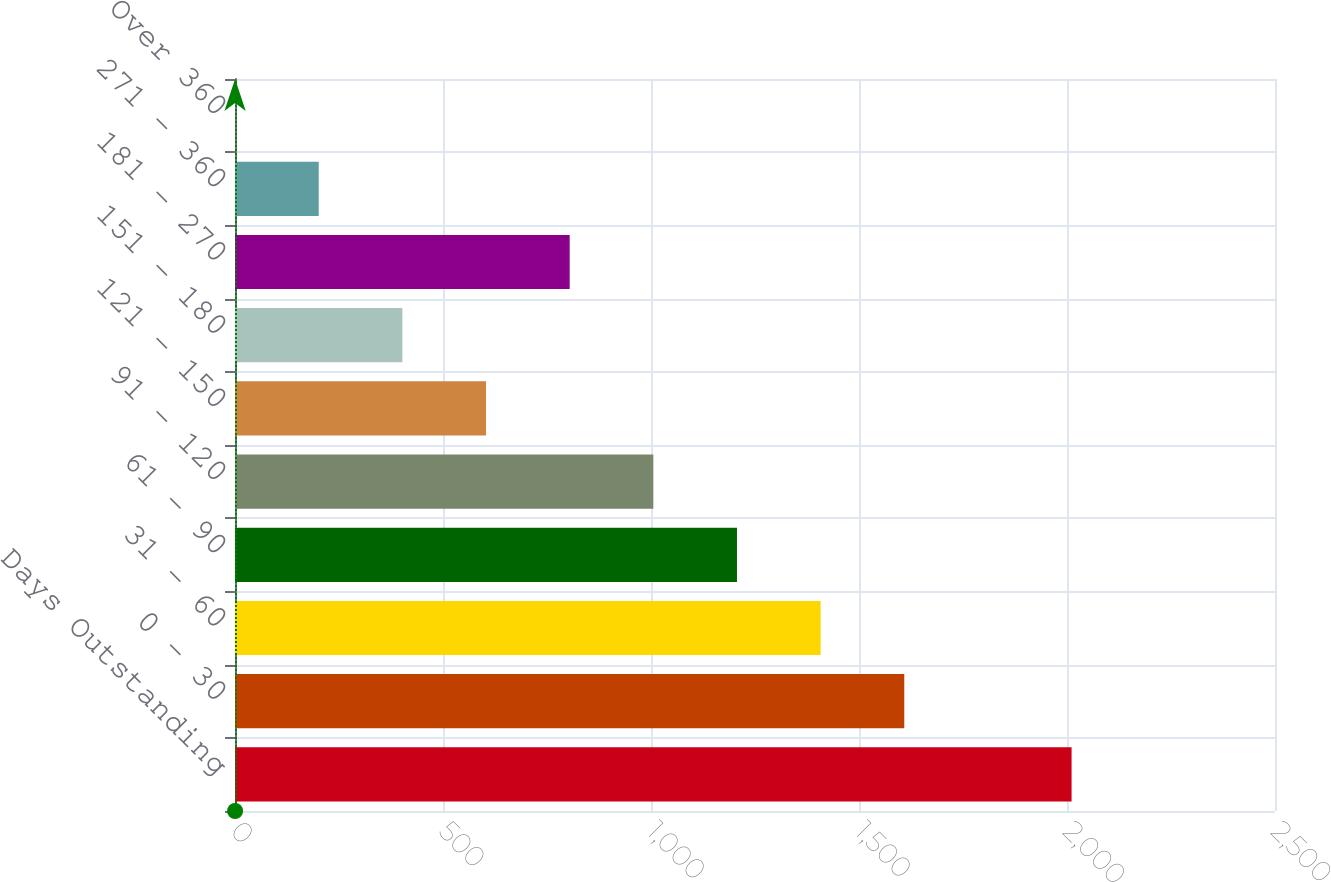Convert chart. <chart><loc_0><loc_0><loc_500><loc_500><bar_chart><fcel>Days Outstanding<fcel>0 - 30<fcel>31 - 60<fcel>61 - 90<fcel>91 - 120<fcel>121 - 150<fcel>151 - 180<fcel>181 - 270<fcel>271 - 360<fcel>Over 360<nl><fcel>2011<fcel>1608.84<fcel>1407.76<fcel>1206.68<fcel>1005.6<fcel>603.44<fcel>402.36<fcel>804.52<fcel>201.28<fcel>0.2<nl></chart> 